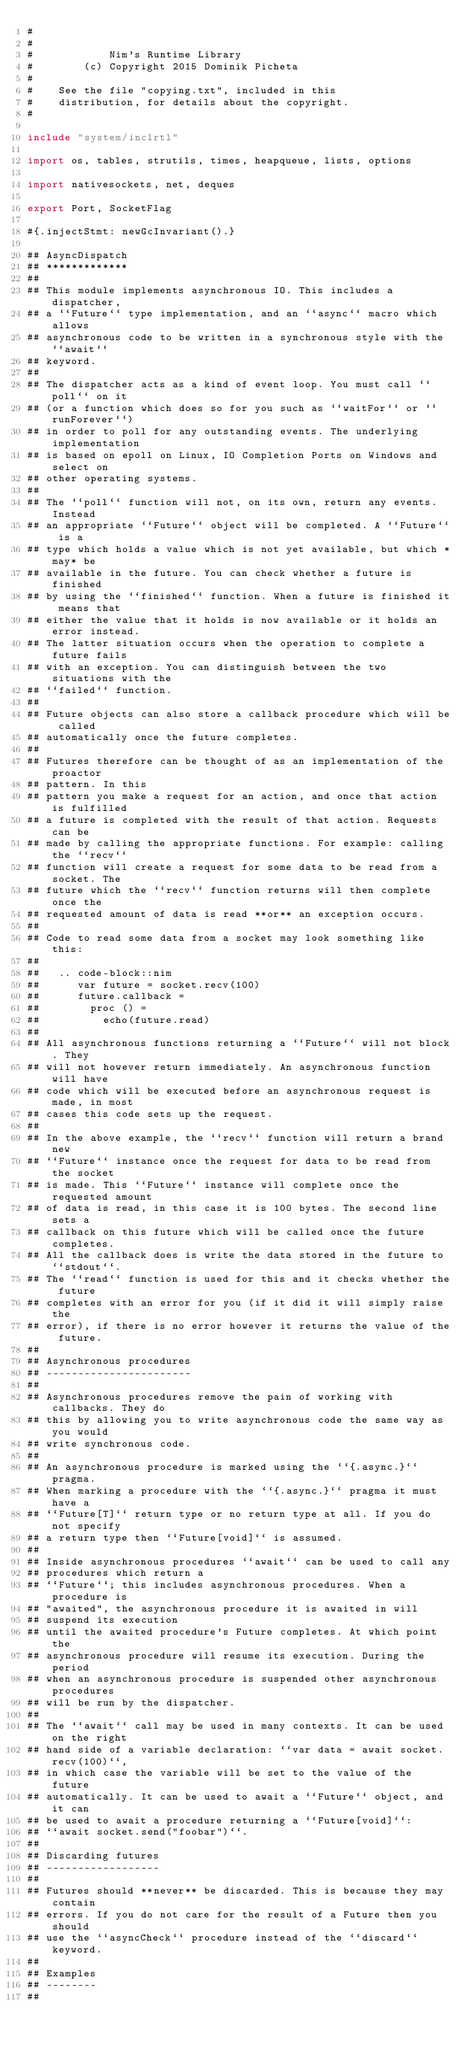<code> <loc_0><loc_0><loc_500><loc_500><_Nim_>#
#
#            Nim's Runtime Library
#        (c) Copyright 2015 Dominik Picheta
#
#    See the file "copying.txt", included in this
#    distribution, for details about the copyright.
#

include "system/inclrtl"

import os, tables, strutils, times, heapqueue, lists, options

import nativesockets, net, deques

export Port, SocketFlag

#{.injectStmt: newGcInvariant().}

## AsyncDispatch
## *************
##
## This module implements asynchronous IO. This includes a dispatcher,
## a ``Future`` type implementation, and an ``async`` macro which allows
## asynchronous code to be written in a synchronous style with the ``await``
## keyword.
##
## The dispatcher acts as a kind of event loop. You must call ``poll`` on it
## (or a function which does so for you such as ``waitFor`` or ``runForever``)
## in order to poll for any outstanding events. The underlying implementation
## is based on epoll on Linux, IO Completion Ports on Windows and select on
## other operating systems.
##
## The ``poll`` function will not, on its own, return any events. Instead
## an appropriate ``Future`` object will be completed. A ``Future`` is a
## type which holds a value which is not yet available, but which *may* be
## available in the future. You can check whether a future is finished
## by using the ``finished`` function. When a future is finished it means that
## either the value that it holds is now available or it holds an error instead.
## The latter situation occurs when the operation to complete a future fails
## with an exception. You can distinguish between the two situations with the
## ``failed`` function.
##
## Future objects can also store a callback procedure which will be called
## automatically once the future completes.
##
## Futures therefore can be thought of as an implementation of the proactor
## pattern. In this
## pattern you make a request for an action, and once that action is fulfilled
## a future is completed with the result of that action. Requests can be
## made by calling the appropriate functions. For example: calling the ``recv``
## function will create a request for some data to be read from a socket. The
## future which the ``recv`` function returns will then complete once the
## requested amount of data is read **or** an exception occurs.
##
## Code to read some data from a socket may look something like this:
##
##   .. code-block::nim
##      var future = socket.recv(100)
##      future.callback =
##        proc () =
##          echo(future.read)
##
## All asynchronous functions returning a ``Future`` will not block. They
## will not however return immediately. An asynchronous function will have
## code which will be executed before an asynchronous request is made, in most
## cases this code sets up the request.
##
## In the above example, the ``recv`` function will return a brand new
## ``Future`` instance once the request for data to be read from the socket
## is made. This ``Future`` instance will complete once the requested amount
## of data is read, in this case it is 100 bytes. The second line sets a
## callback on this future which will be called once the future completes.
## All the callback does is write the data stored in the future to ``stdout``.
## The ``read`` function is used for this and it checks whether the future
## completes with an error for you (if it did it will simply raise the
## error), if there is no error however it returns the value of the future.
##
## Asynchronous procedures
## -----------------------
##
## Asynchronous procedures remove the pain of working with callbacks. They do
## this by allowing you to write asynchronous code the same way as you would
## write synchronous code.
##
## An asynchronous procedure is marked using the ``{.async.}`` pragma.
## When marking a procedure with the ``{.async.}`` pragma it must have a
## ``Future[T]`` return type or no return type at all. If you do not specify
## a return type then ``Future[void]`` is assumed.
##
## Inside asynchronous procedures ``await`` can be used to call any
## procedures which return a
## ``Future``; this includes asynchronous procedures. When a procedure is
## "awaited", the asynchronous procedure it is awaited in will
## suspend its execution
## until the awaited procedure's Future completes. At which point the
## asynchronous procedure will resume its execution. During the period
## when an asynchronous procedure is suspended other asynchronous procedures
## will be run by the dispatcher.
##
## The ``await`` call may be used in many contexts. It can be used on the right
## hand side of a variable declaration: ``var data = await socket.recv(100)``,
## in which case the variable will be set to the value of the future
## automatically. It can be used to await a ``Future`` object, and it can
## be used to await a procedure returning a ``Future[void]``:
## ``await socket.send("foobar")``.
##
## Discarding futures
## ------------------
##
## Futures should **never** be discarded. This is because they may contain
## errors. If you do not care for the result of a Future then you should
## use the ``asyncCheck`` procedure instead of the ``discard`` keyword.
##
## Examples
## --------
##</code> 